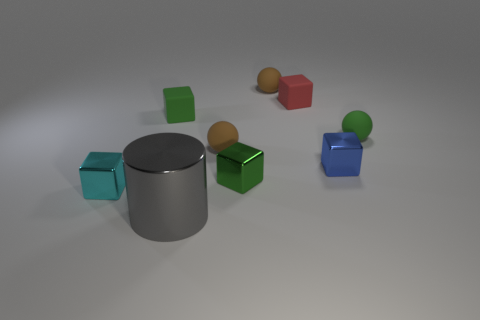Are the cyan object and the thing in front of the tiny cyan metal thing made of the same material?
Give a very brief answer. Yes. How many other objects are there of the same shape as the tiny green metal thing?
Ensure brevity in your answer.  4. Do the large metallic cylinder and the tiny sphere to the right of the small blue metallic thing have the same color?
Your answer should be compact. No. Is there any other thing that has the same material as the large cylinder?
Give a very brief answer. Yes. What is the shape of the small brown matte thing that is to the right of the tiny green block that is on the right side of the gray metal thing?
Keep it short and to the point. Sphere. There is a small cyan thing that is on the left side of the large metal cylinder; is its shape the same as the tiny red rubber thing?
Provide a short and direct response. Yes. Is the number of red rubber things in front of the gray cylinder greater than the number of green rubber spheres that are in front of the green matte ball?
Make the answer very short. No. How many shiny things are on the left side of the small green object that is in front of the small green sphere?
Give a very brief answer. 2. What is the color of the small rubber ball that is behind the small rubber ball that is to the right of the tiny blue block?
Offer a terse response. Brown. Are there any tiny things of the same color as the cylinder?
Make the answer very short. No. 